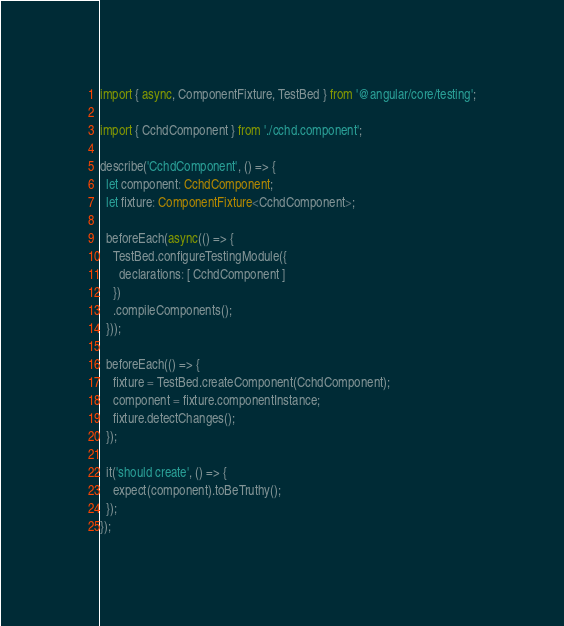<code> <loc_0><loc_0><loc_500><loc_500><_TypeScript_>import { async, ComponentFixture, TestBed } from '@angular/core/testing';

import { CchdComponent } from './cchd.component';

describe('CchdComponent', () => {
  let component: CchdComponent;
  let fixture: ComponentFixture<CchdComponent>;

  beforeEach(async(() => {
    TestBed.configureTestingModule({
      declarations: [ CchdComponent ]
    })
    .compileComponents();
  }));

  beforeEach(() => {
    fixture = TestBed.createComponent(CchdComponent);
    component = fixture.componentInstance;
    fixture.detectChanges();
  });

  it('should create', () => {
    expect(component).toBeTruthy();
  });
});
</code> 